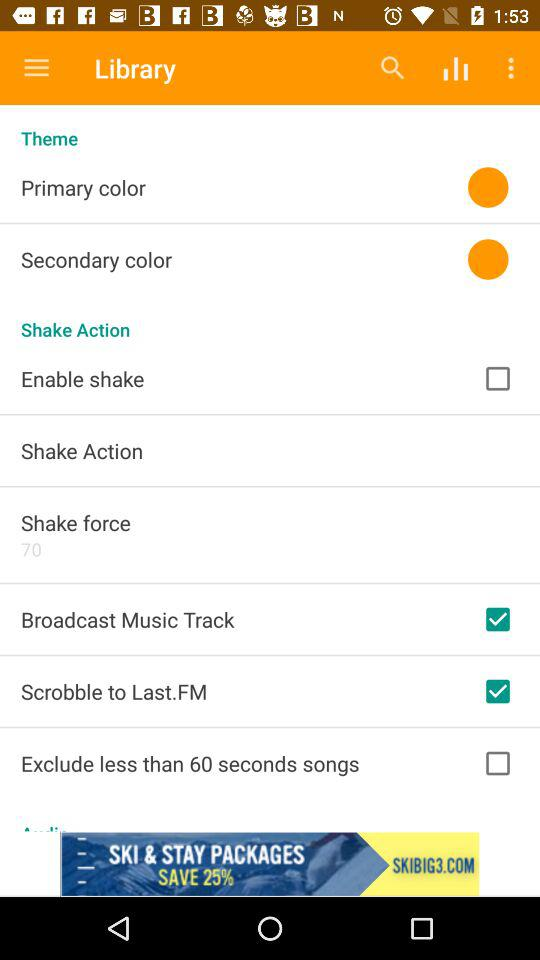What is the current status of the enable shake? The status is off. 